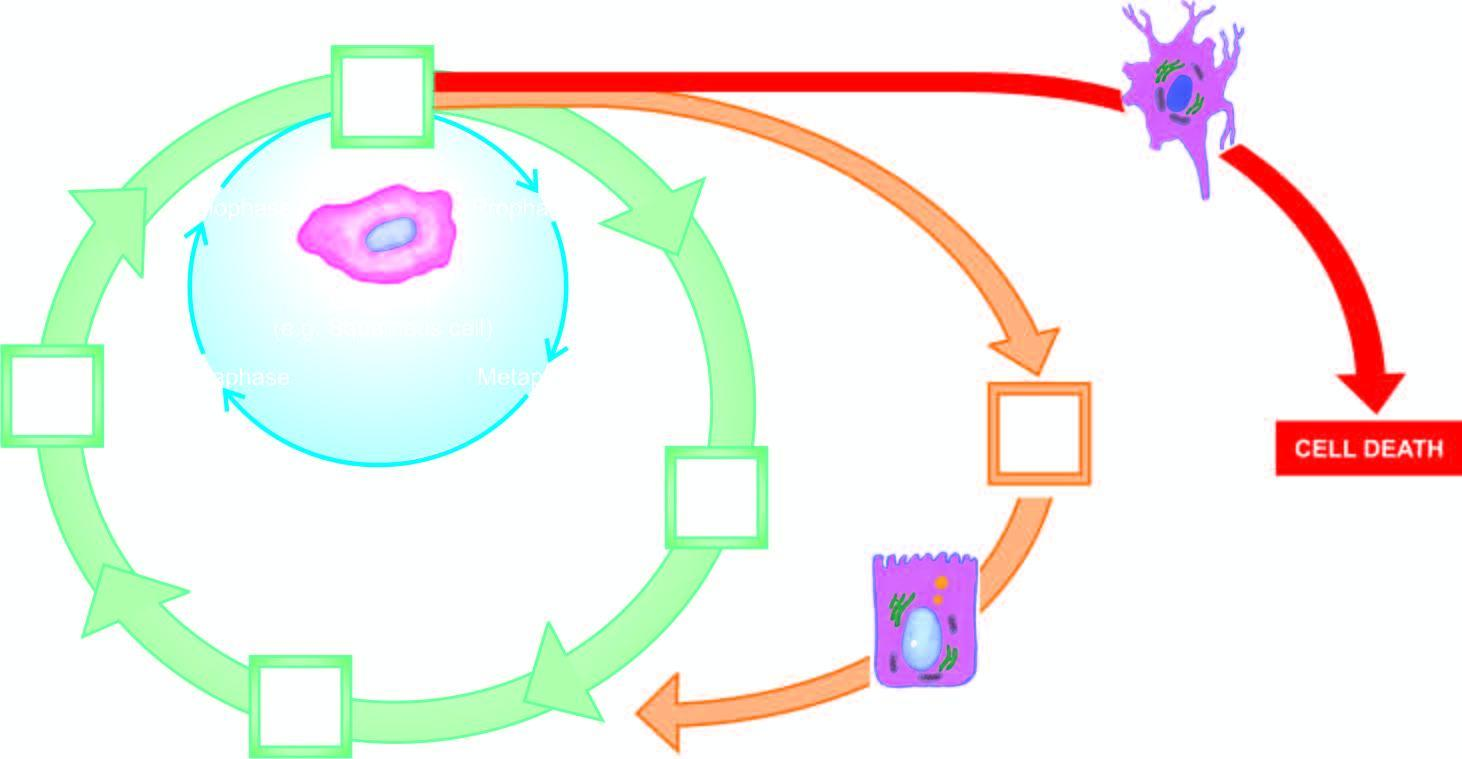what is the inner circle shown with?
Answer the question using a single word or phrase. Green line 